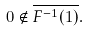Convert formula to latex. <formula><loc_0><loc_0><loc_500><loc_500>0 \notin \overline { F ^ { - 1 } ( 1 ) } .</formula> 